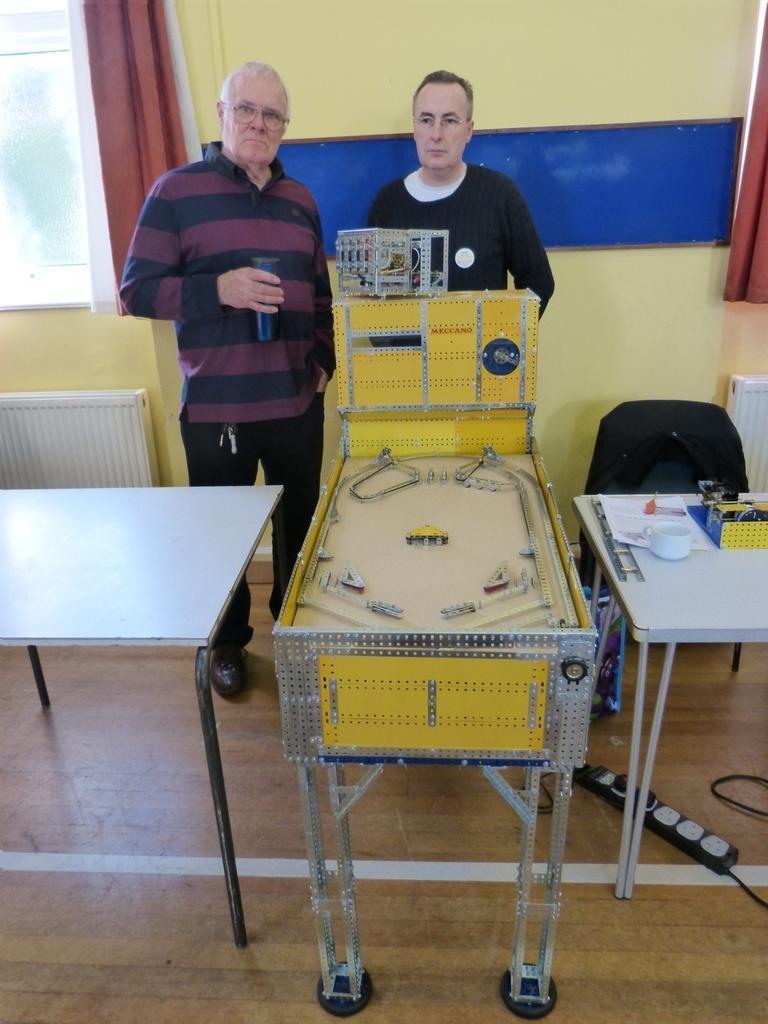Could you give a brief overview of what you see in this image? In this image I can see two men are standing. I can also see curtains and few tables. I can see he is holding a bottle and also wearing a specs. 